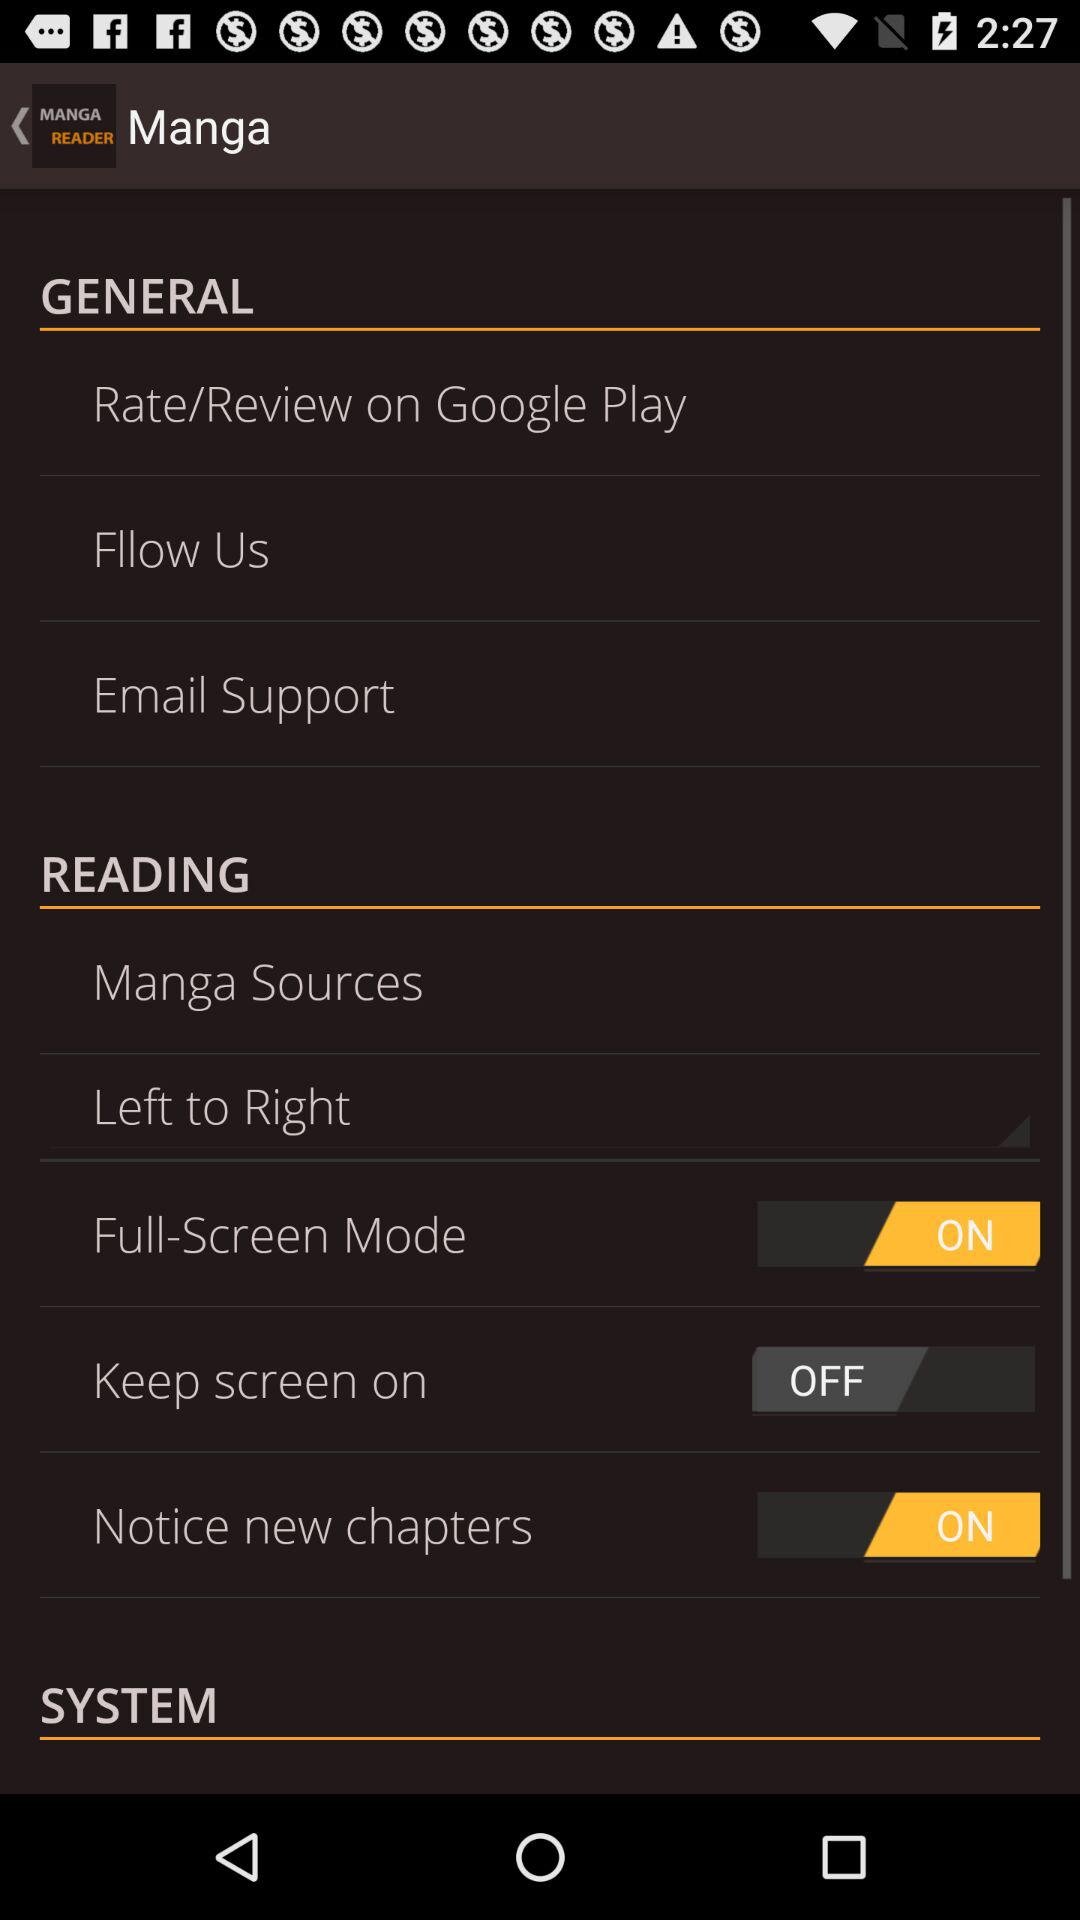What is the name of the application? The application name is "MANGA READER". 